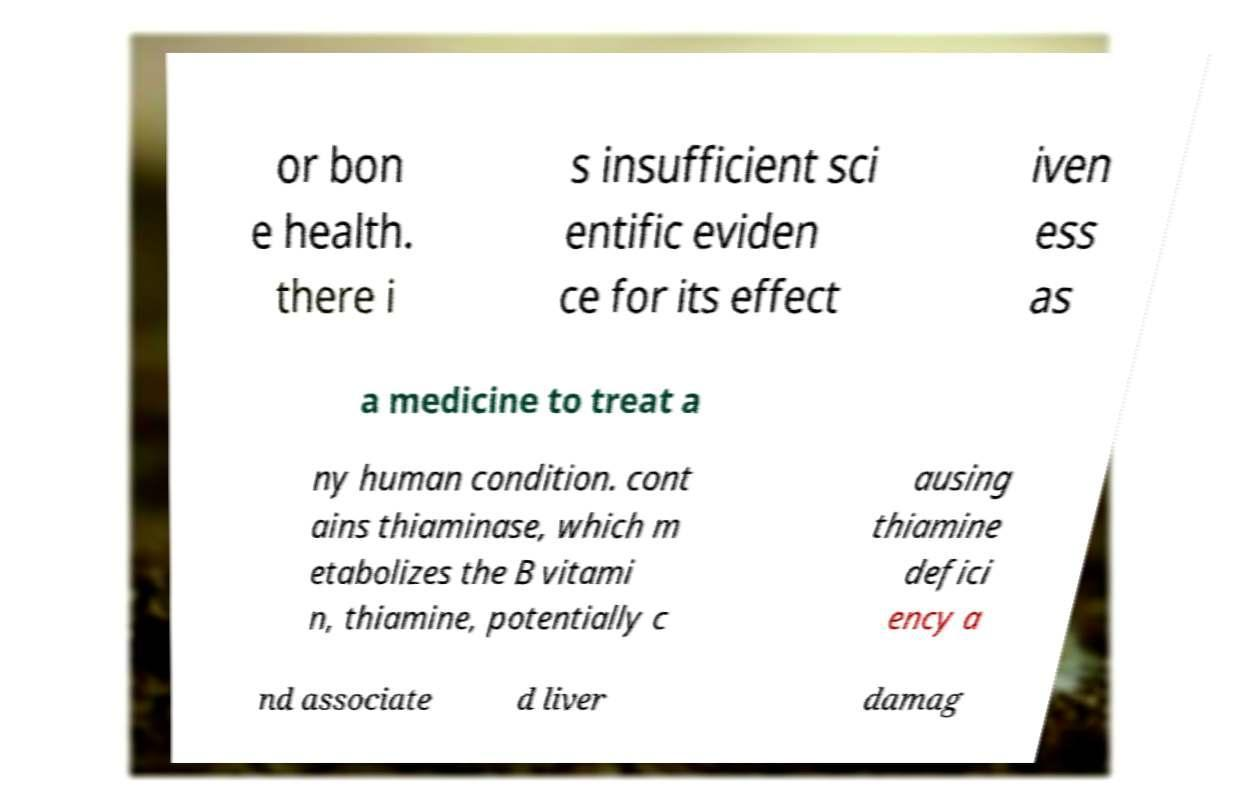What messages or text are displayed in this image? I need them in a readable, typed format. or bon e health. there i s insufficient sci entific eviden ce for its effect iven ess as a medicine to treat a ny human condition. cont ains thiaminase, which m etabolizes the B vitami n, thiamine, potentially c ausing thiamine defici ency a nd associate d liver damag 